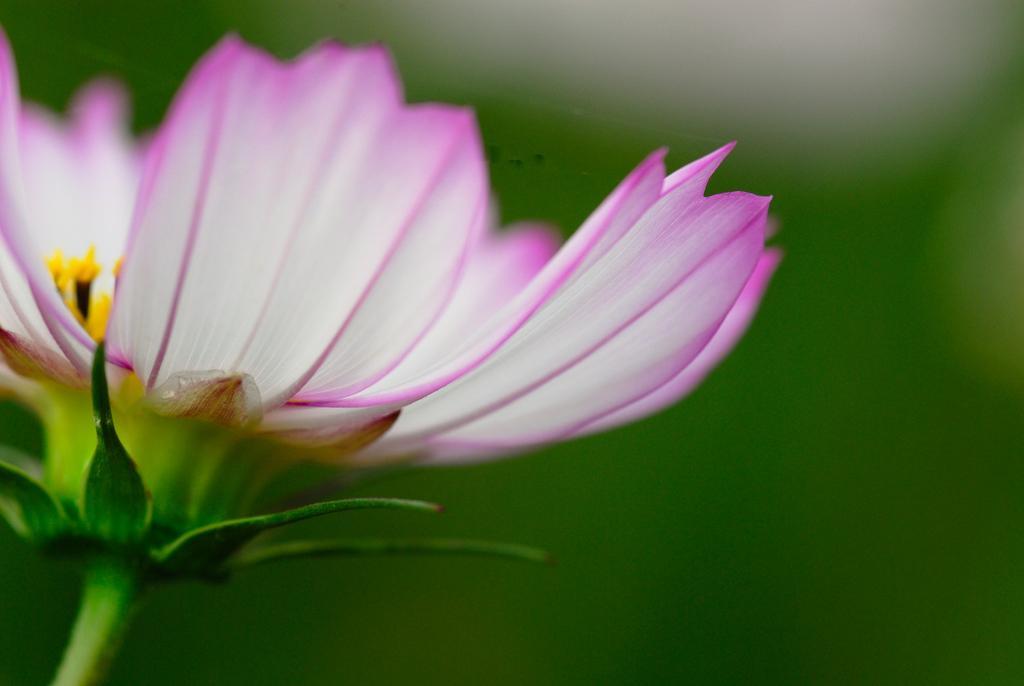In one or two sentences, can you explain what this image depicts? In this image we can see a flower which is in a combination of pink and white color. 